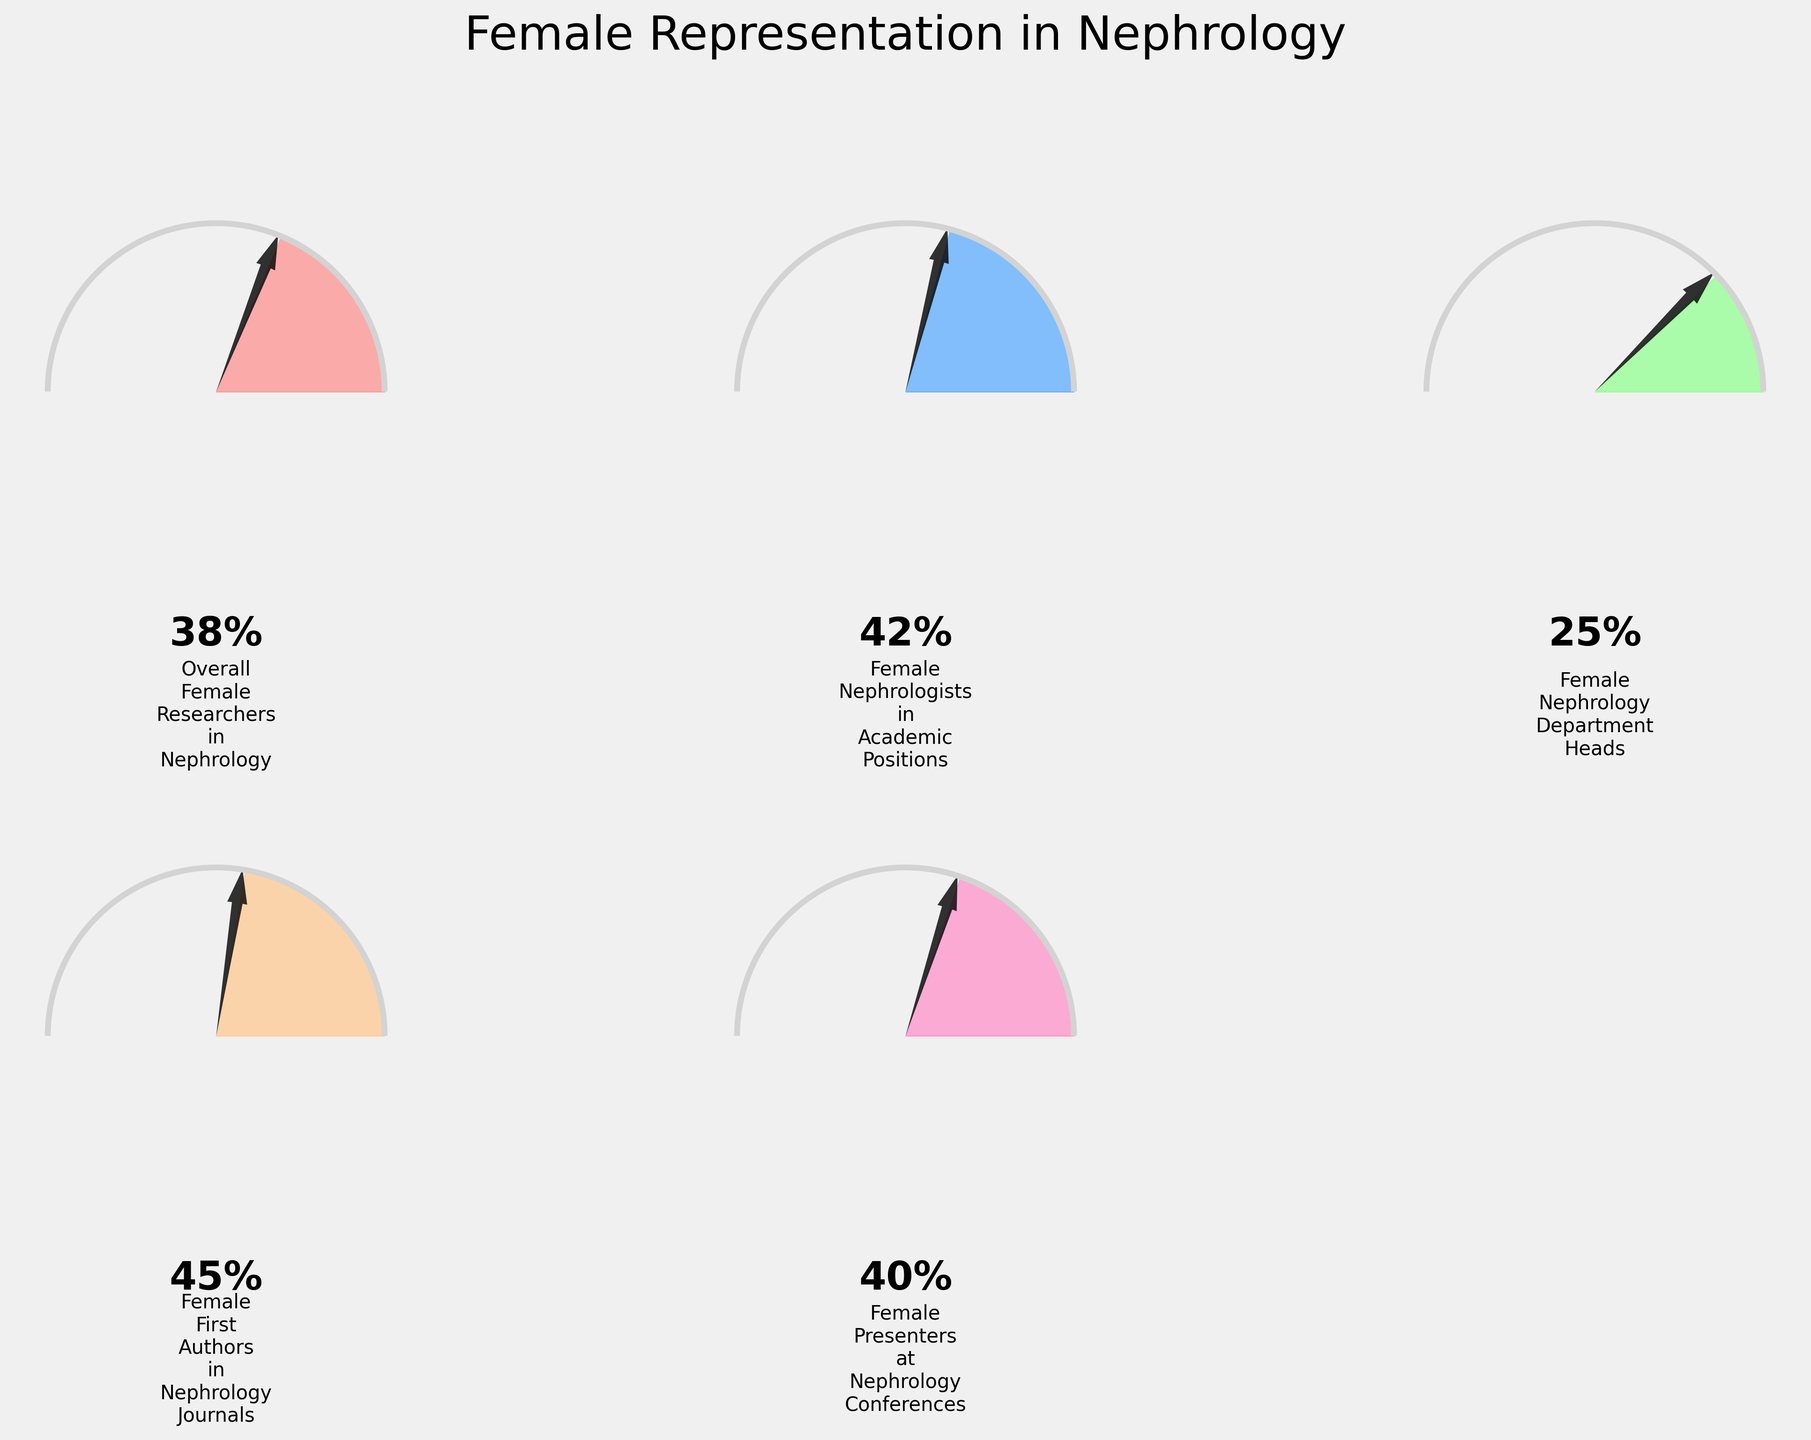How many categories of female representation in nephrology are shown in the figure? The figure displays several gauge charts, each representing a different category of female representation in nephrology. Count the number of separate charts in the figure.
Answer: 5 What is the category with the highest percentage of female representation in nephrology based on the figure? Look at each gauge chart and identify which one shows the highest percentage.
Answer: Female First Authors in Nephrology Journals What is the difference in percentage between Female Nephrology Department Heads and Female First Authors in Nephrology Journals? Subtract the percentage of Female Nephrology Department Heads from that of Female First Authors in Nephrology Journals (45 - 25).
Answer: 20% Which two categories have similar percentages of female representation, as observed in the figure? Compare the percentages shown in the gauge charts to identify the two categories with close values.
Answer: Overall Female Researchers in Nephrology and Female Presenters at Nephrology Conferences (38% and 40%) What can be inferred about the percentage of female nephrologists in academic positions compared to overall female nephrologists? Compare the two relevant gauge charts: Female Nephrologists in Academic Positions and Overall Female Researchers in Nephrology. Note which one has the higher percentage.
Answer: Female nephrologists in academic positions have a higher percentage (42% vs. 38%) Which category shows the lowest representation of female researchers in nephrology? Identify the gauge chart with the lowest percentage displayed.
Answer: Female Nephrology Department Heads By how many percentage points does the representation of female presenters at nephrology conferences exceed that of female nephrology department heads? Subtract the percentage of Female Nephrology Department Heads from that of Female Presenters at Nephrology Conferences (40 - 25).
Answer: 15% What is the average percentage of female representation across all categories shown in the figure? Add up all the percentages and then divide by the number of categories (38 + 42 + 25 + 45 + 40) / 5.
Answer: 38% Which category's gauge chart shows a percentage closest to 50%? Examine each gauge chart and identify which percentage is closest to 50%.
Answer: Female First Authors in Nephrology Journals If improvement policies were to increase the percentage of female nephrology department heads by 10%, what would the new percentage be? Add 10 percentage points to the current percentage of Female Nephrology Department Heads (25 + 10).
Answer: 35% 